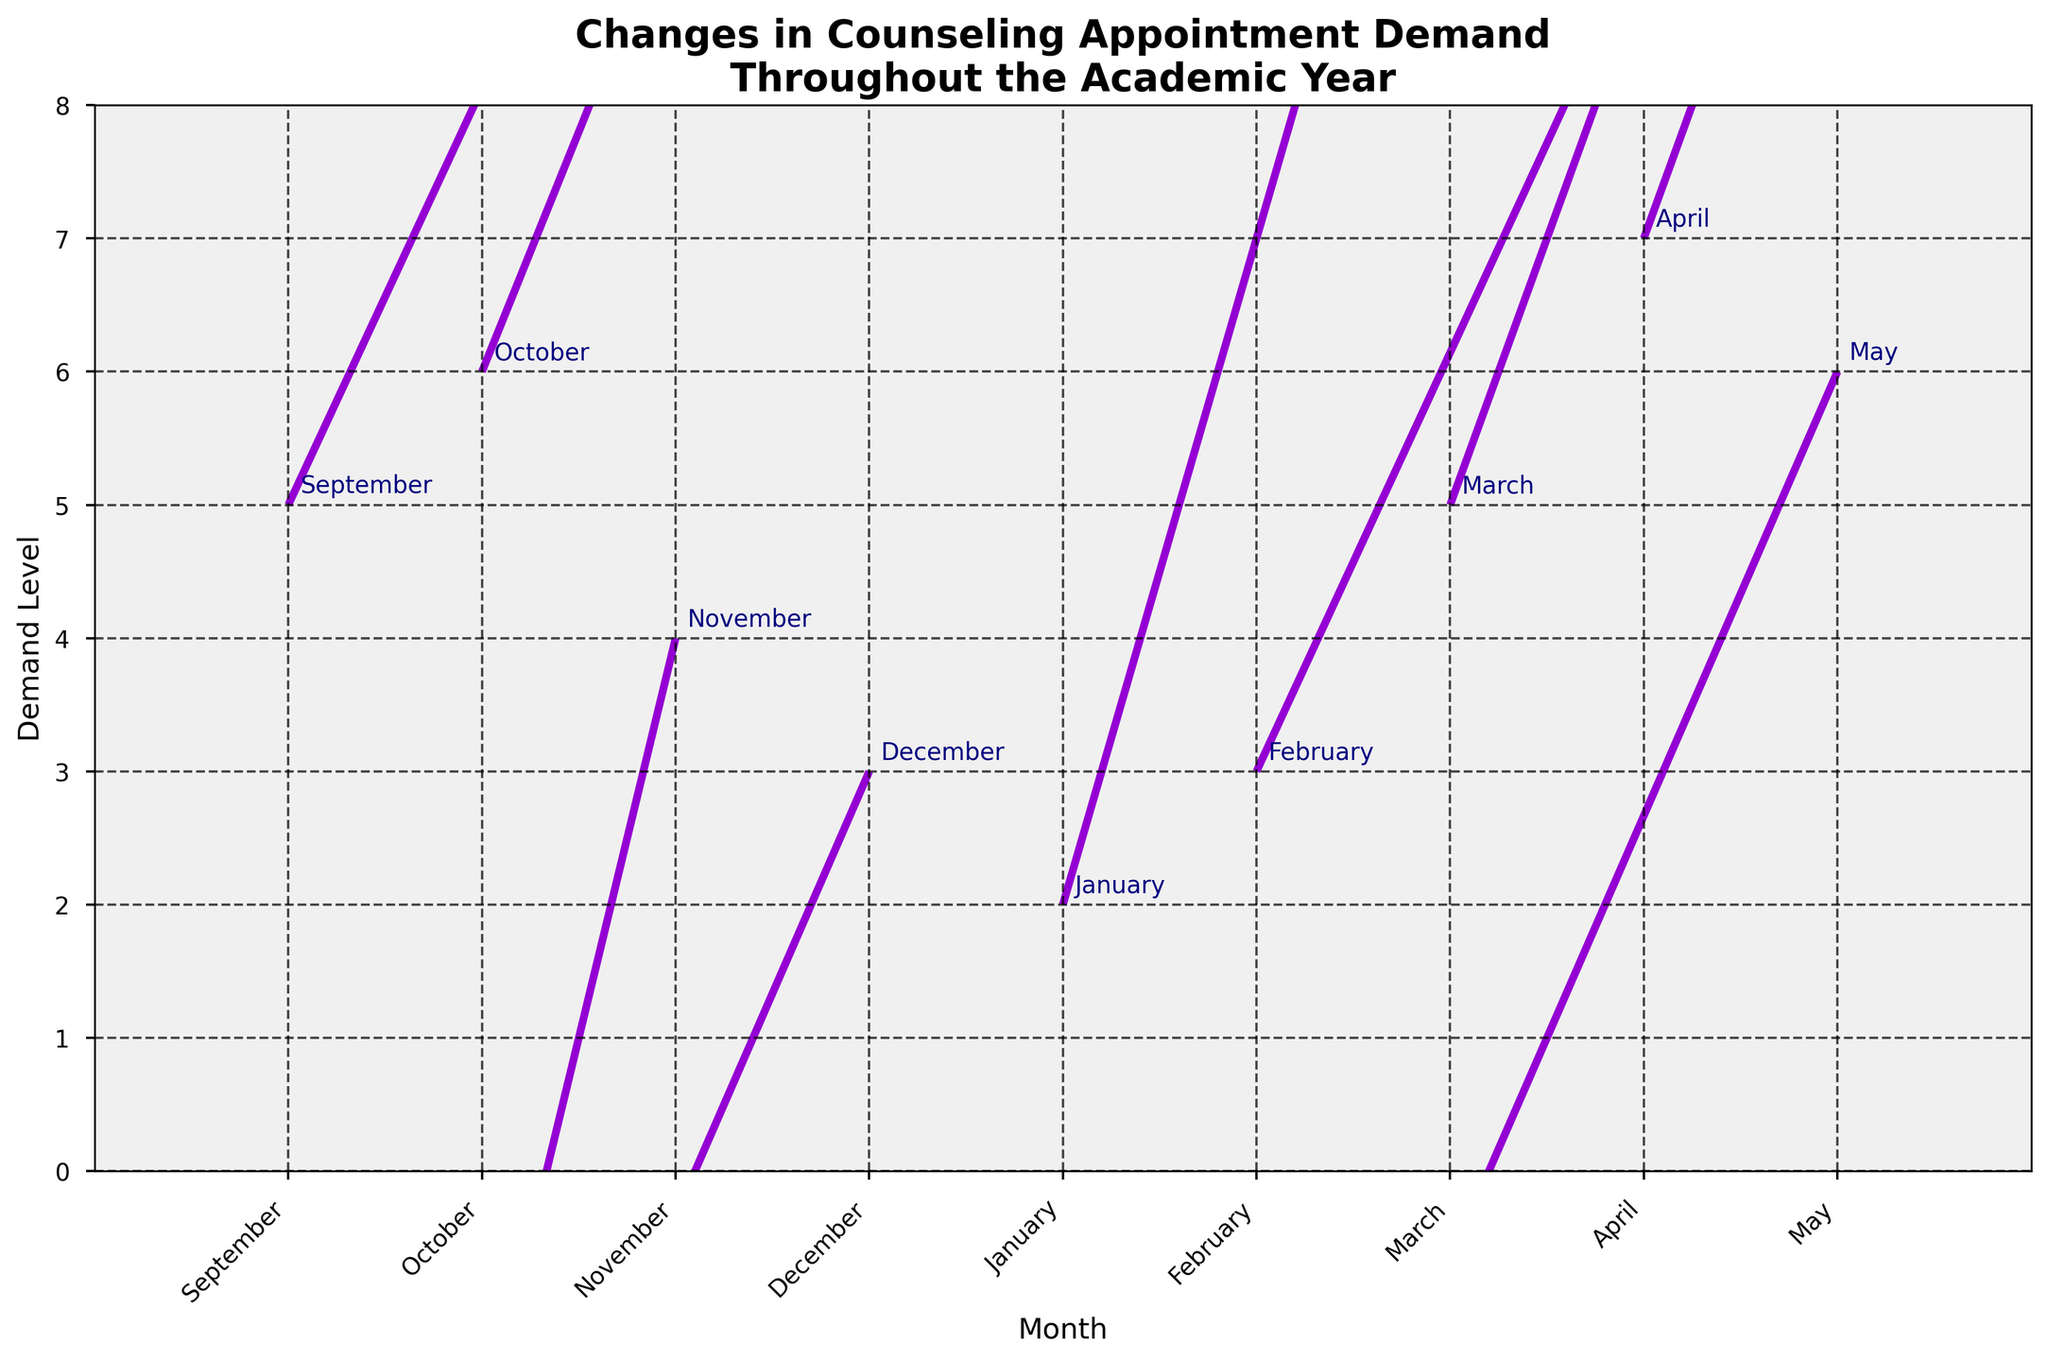what is the title of the chart? The title of the chart is typically located at the top of the figure. By looking at the top, you'll see the title that was set for this quiver plot.
Answer: Changes in Counseling Appointment Demand Throughout the Academic Year what is the color of the arrows? The color of the arrows can be identified based on their appearance in the plot. All arrows in the plot have been set to the same color.
Answer: darkviolet What's the value range of the y-axis? To determine the value range of the y-axis, look at the lowest and highest values marked on the y-axis. The figure shows these values.
Answer: 0 to 8 Which month has the highest demand level initially? The demand levels are represented by the initial positions on the y-axis. Look for the month with the highest initial y-value.
Answer: April In which months does the demand level decrease? To identify months with a decrease in demand, look for arrows pointing downward, i.e., with negative V values in the plot.
Answer: November, December, and May How does the demand change from September to December? Evaluate the arrows' direction and length from September to December. Summarize these changes by observing if the arrows point up or down and their magnitude.
Answer: Increases in September and October, decreases in November and December What is the overall trend of demand from January to March? Determine the overall trend by observing the arrows from January to March, noting the direction and magnitude.
Answer: Increasing Which month has the smallest change in demand level? Look for the arrow with the smallest magnitude of V (the vertical change component).
Answer: April Which month has a positive but smallest increase in demand? Identify the months with positive V values and then find the one with the smallest V.
Answer: October Compare the demand changes in February and May. Which has a greater magnitude, and is it an increase or decrease? Calculate the magnitude of changes by looking at the length and direction of arrows for February and May. Compare both values based on the visual length of these vectors.
Answer: February has a greater magnitude and it's an increase, while May shows a decrease 